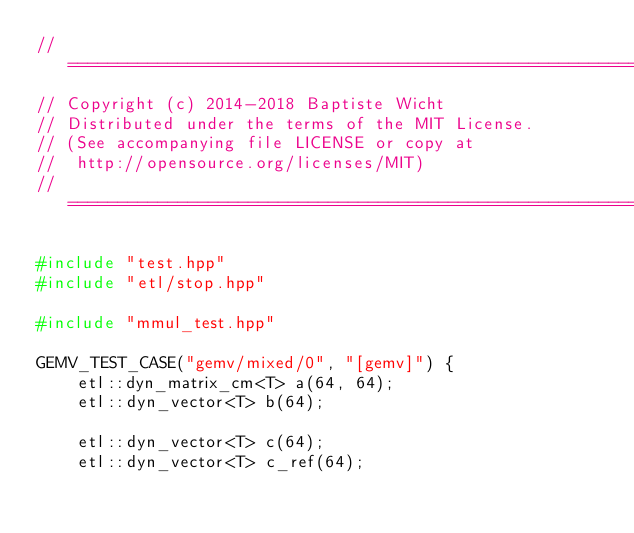<code> <loc_0><loc_0><loc_500><loc_500><_C++_>//=======================================================================
// Copyright (c) 2014-2018 Baptiste Wicht
// Distributed under the terms of the MIT License.
// (See accompanying file LICENSE or copy at
//  http://opensource.org/licenses/MIT)
//=======================================================================

#include "test.hpp"
#include "etl/stop.hpp"

#include "mmul_test.hpp"

GEMV_TEST_CASE("gemv/mixed/0", "[gemv]") {
    etl::dyn_matrix_cm<T> a(64, 64);
    etl::dyn_vector<T> b(64);

    etl::dyn_vector<T> c(64);
    etl::dyn_vector<T> c_ref(64);
</code> 